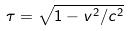Convert formula to latex. <formula><loc_0><loc_0><loc_500><loc_500>\tau = \sqrt { 1 - v ^ { 2 } / c ^ { 2 } }</formula> 